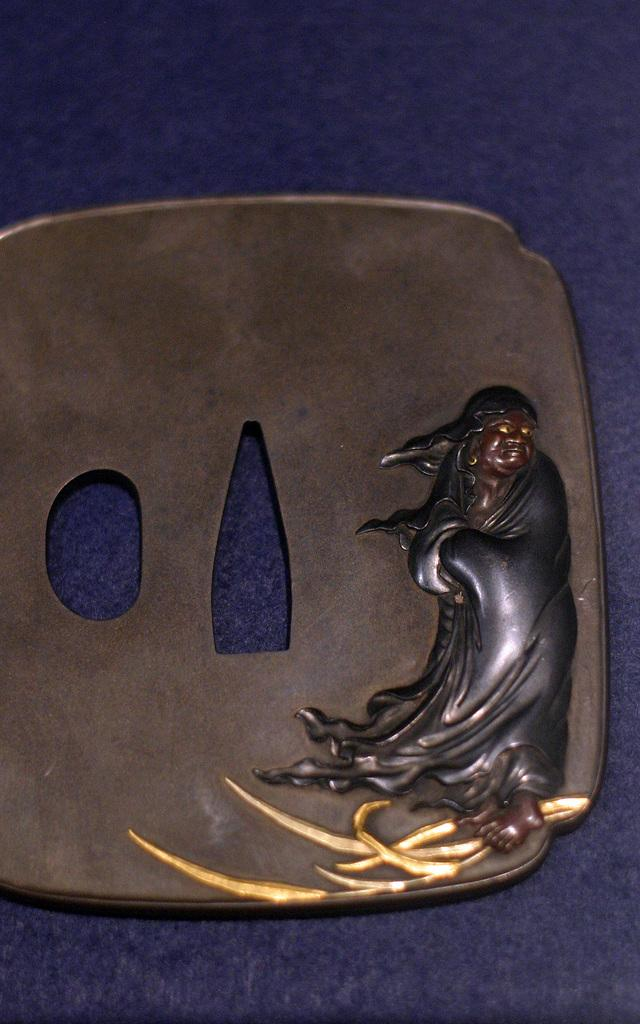What color is the surface visible in the image? The surface in the image is blue. What is on top of the blue surface? There is a piece of object on the blue surface. What can be observed on the object? The object has sculpture on it. Can you tell me how many celery stalks are in the sculpture on the object? There is no celery present in the image, and therefore no celery stalks can be counted in the sculpture. 